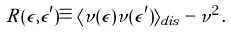<formula> <loc_0><loc_0><loc_500><loc_500>R ( \epsilon , \epsilon ^ { \prime } ) \equiv \langle \nu ( \epsilon ) \nu ( \epsilon ^ { \prime } ) \rangle _ { d i s } - \nu ^ { 2 } \, .</formula> 